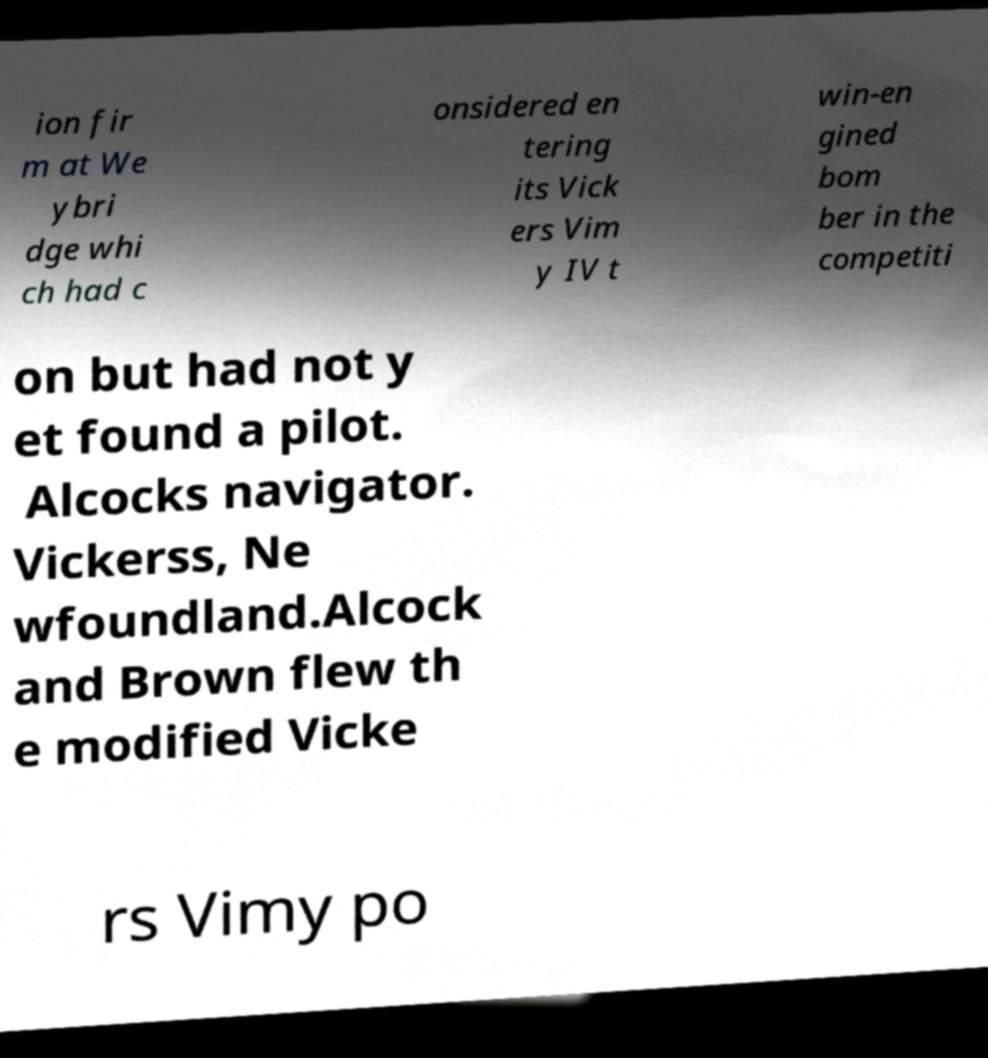Please identify and transcribe the text found in this image. ion fir m at We ybri dge whi ch had c onsidered en tering its Vick ers Vim y IV t win-en gined bom ber in the competiti on but had not y et found a pilot. Alcocks navigator. Vickerss, Ne wfoundland.Alcock and Brown flew th e modified Vicke rs Vimy po 